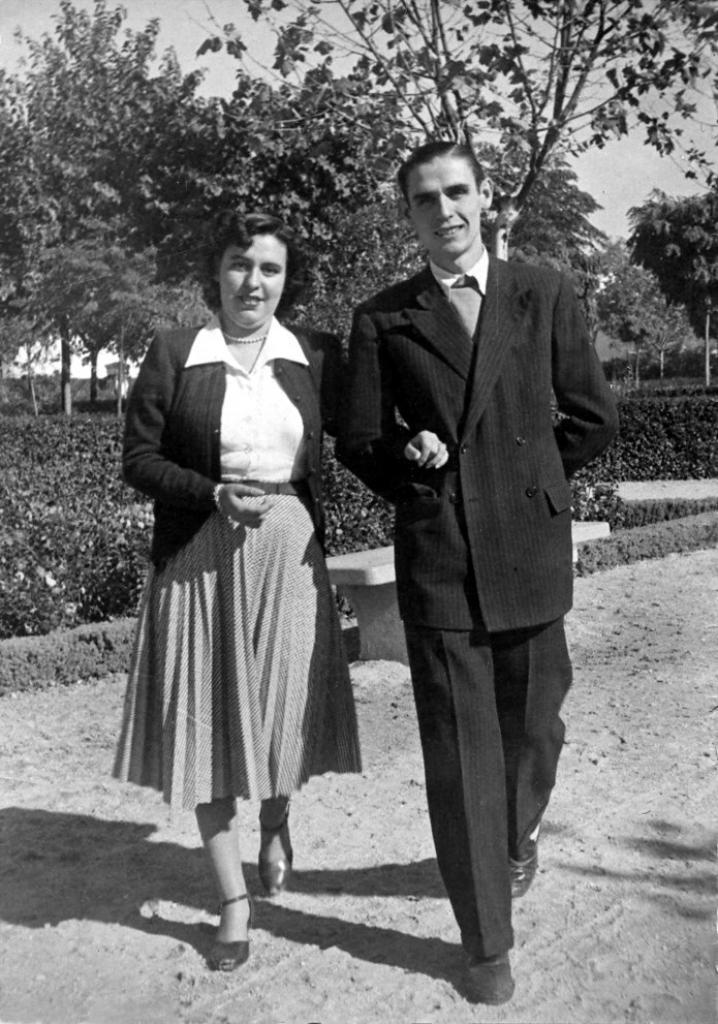Who is present in the image? There is a man and a woman in the image. What is the man wearing? The man is wearing a black suit. What is the woman wearing? The woman is wearing a skirt. What can be seen in the background of the image? There are trees and plants in the background of the image. What type of cracker is on the shelf in the image? There is no cracker or shelf present in the image. How many rays are visible in the image? There are no rays visible in the image. 